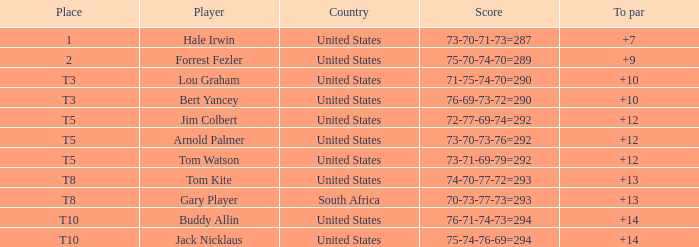Which country's score of 72-77-69-74=292 resulted in a reward of over $5,500? United States. 